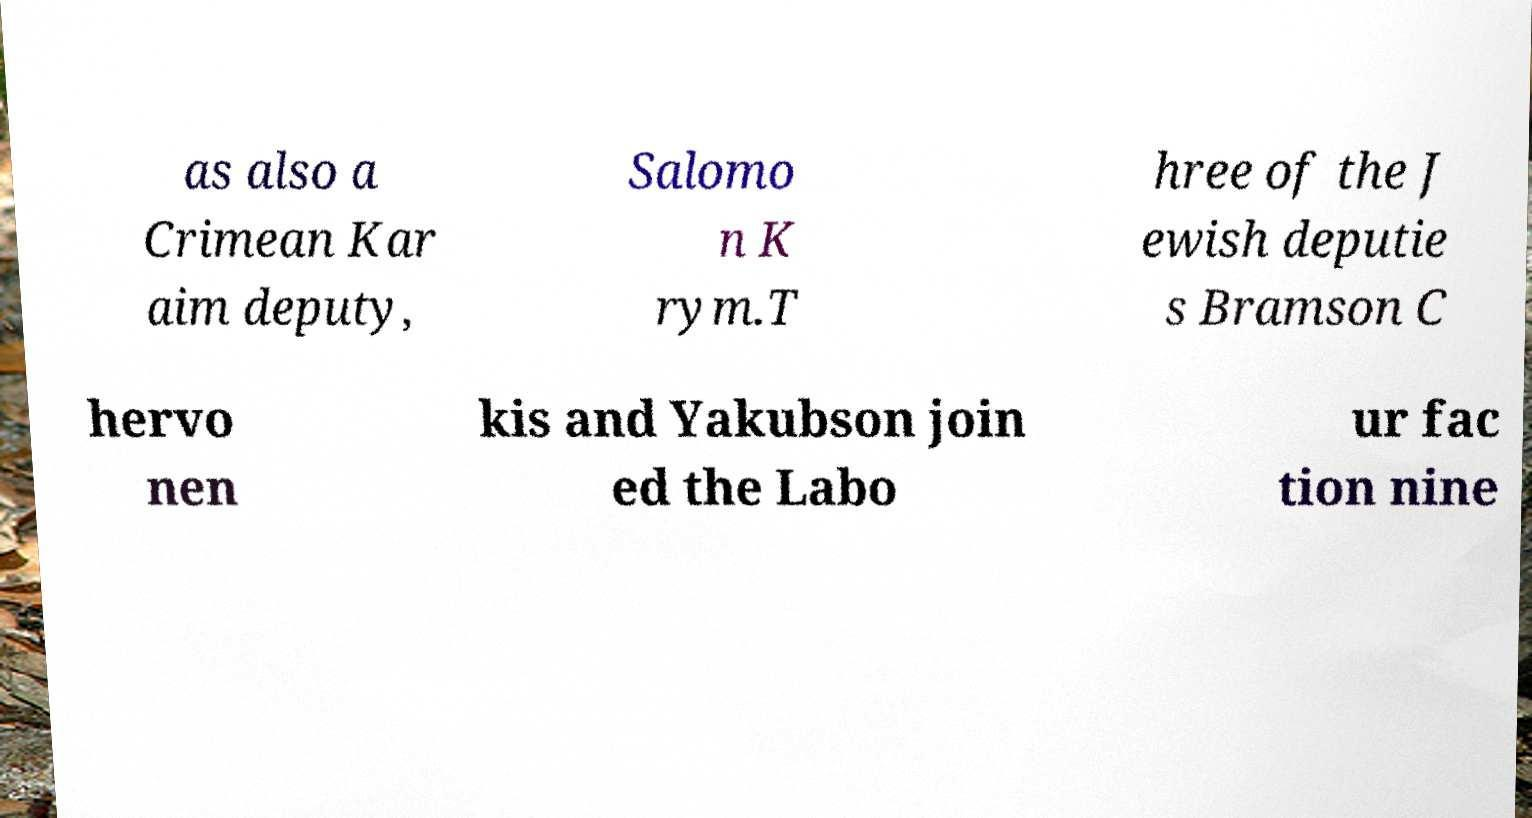For documentation purposes, I need the text within this image transcribed. Could you provide that? as also a Crimean Kar aim deputy, Salomo n K rym.T hree of the J ewish deputie s Bramson C hervo nen kis and Yakubson join ed the Labo ur fac tion nine 